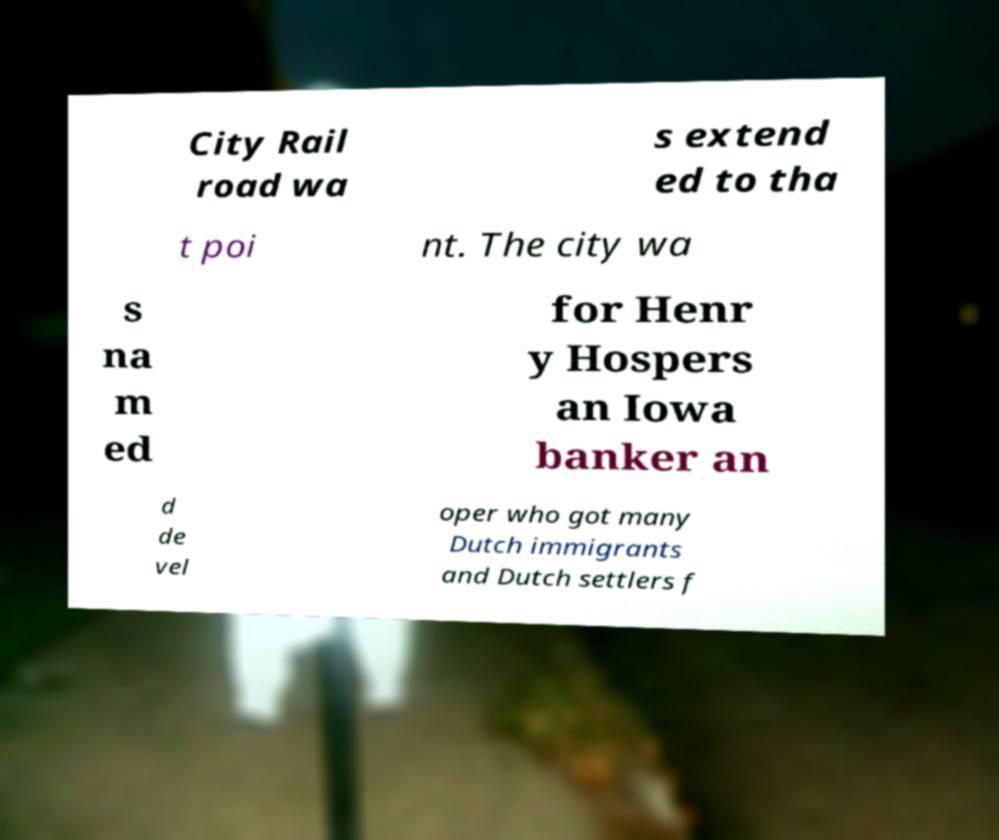For documentation purposes, I need the text within this image transcribed. Could you provide that? City Rail road wa s extend ed to tha t poi nt. The city wa s na m ed for Henr y Hospers an Iowa banker an d de vel oper who got many Dutch immigrants and Dutch settlers f 